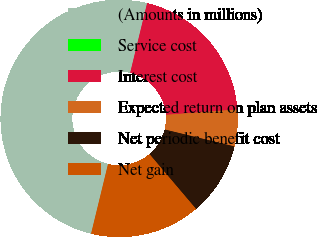Convert chart to OTSL. <chart><loc_0><loc_0><loc_500><loc_500><pie_chart><fcel>(Amounts in millions)<fcel>Service cost<fcel>Interest cost<fcel>Expected return on plan assets<fcel>Net periodic benefit cost<fcel>Net gain<nl><fcel>49.99%<fcel>0.0%<fcel>20.0%<fcel>5.0%<fcel>10.0%<fcel>15.0%<nl></chart> 